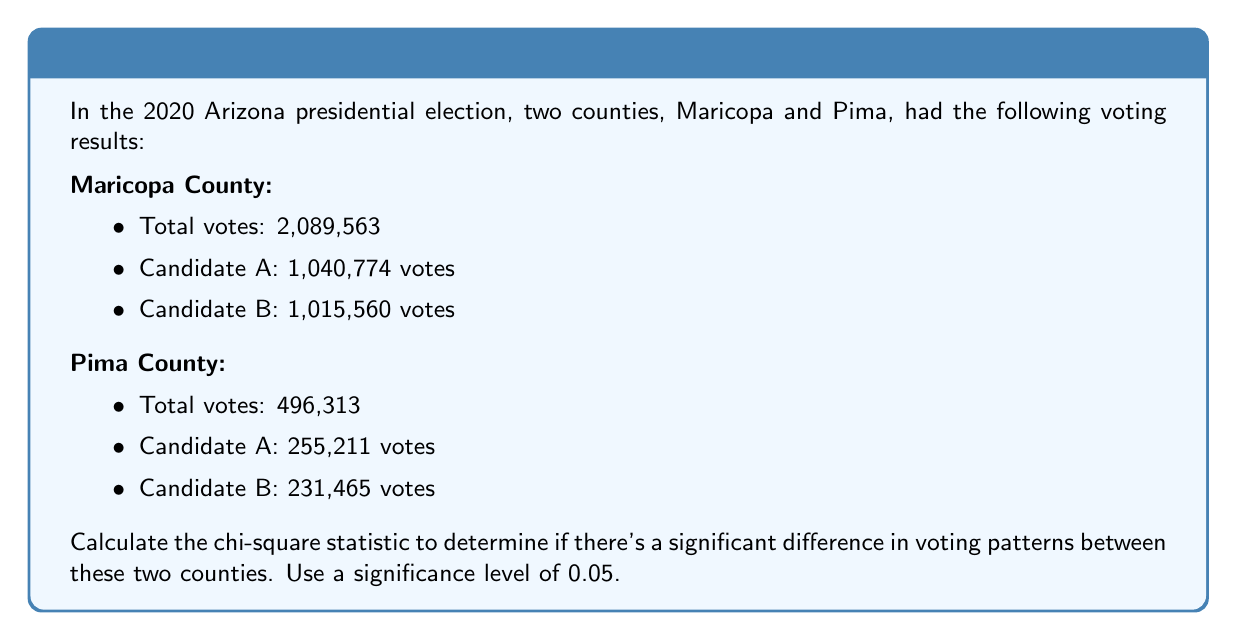What is the answer to this math problem? To compare the voting patterns between Maricopa and Pima counties, we'll use the chi-square test of independence. This test helps us determine if there's a significant difference in how people voted in these two counties.

Step 1: Set up the observed frequencies in a 2x2 table.

Maricopa: [1040774, 1015560]
Pima:     [255211, 231465]

Step 2: Calculate the expected frequencies.
For each cell, the expected frequency is:
$$ E = \frac{\text{(Row Total)} \times \text{(Column Total)}}{\text{Grand Total}} $$

Row totals: [2089563, 496313]
Column totals: [1295985, 1247025]
Grand total: 2585876

Expected frequencies:
$$ E_{11} = \frac{2089563 \times 1295985}{2585876} = 1044895.5 $$
$$ E_{12} = \frac{2089563 \times 1247025}{2585876} = 1044667.5 $$
$$ E_{21} = \frac{496313 \times 1295985}{2585876} = 251089.5 $$
$$ E_{22} = \frac{496313 \times 1247025}{2585876} = 245223.5 $$

Step 3: Calculate the chi-square statistic.
$$ \chi^2 = \sum \frac{(O - E)^2}{E} $$

Where O is the observed frequency and E is the expected frequency.

$$ \chi^2 = \frac{(1040774 - 1044895.5)^2}{1044895.5} + \frac{(1015560 - 1044667.5)^2}{1044667.5} + \frac{(255211 - 251089.5)^2}{251089.5} + \frac{(231465 - 245223.5)^2}{245223.5} $$

$$ \chi^2 = 163.4 + 162.0 + 681.9 + 673.9 = 1681.2 $$

Step 4: Determine the degrees of freedom (df).
For a 2x2 table, df = (rows - 1) × (columns - 1) = 1

Step 5: Compare the calculated chi-square value to the critical value.
For df = 1 and α = 0.05, the critical value is 3.841.

Since our calculated χ² (1681.2) is greater than the critical value (3.841), we reject the null hypothesis.
Answer: The chi-square statistic is 1681.2, which is greater than the critical value of 3.841 at a 0.05 significance level. This indicates that there is a statistically significant difference in voting patterns between Maricopa and Pima counties. 